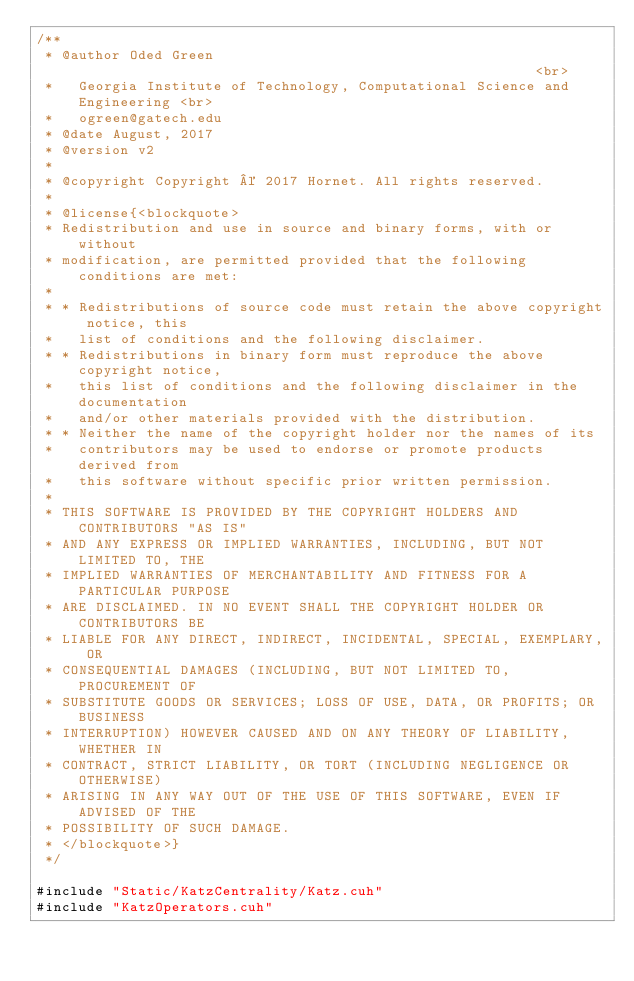<code> <loc_0><loc_0><loc_500><loc_500><_Cuda_>/**
 * @author Oded Green                                                       <br>
 *   Georgia Institute of Technology, Computational Science and Engineering <br>
 *   ogreen@gatech.edu
 * @date August, 2017
 * @version v2
 *
 * @copyright Copyright © 2017 Hornet. All rights reserved.
 *
 * @license{<blockquote>
 * Redistribution and use in source and binary forms, with or without
 * modification, are permitted provided that the following conditions are met:
 *
 * * Redistributions of source code must retain the above copyright notice, this
 *   list of conditions and the following disclaimer.
 * * Redistributions in binary form must reproduce the above copyright notice,
 *   this list of conditions and the following disclaimer in the documentation
 *   and/or other materials provided with the distribution.
 * * Neither the name of the copyright holder nor the names of its
 *   contributors may be used to endorse or promote products derived from
 *   this software without specific prior written permission.
 *
 * THIS SOFTWARE IS PROVIDED BY THE COPYRIGHT HOLDERS AND CONTRIBUTORS "AS IS"
 * AND ANY EXPRESS OR IMPLIED WARRANTIES, INCLUDING, BUT NOT LIMITED TO, THE
 * IMPLIED WARRANTIES OF MERCHANTABILITY AND FITNESS FOR A PARTICULAR PURPOSE
 * ARE DISCLAIMED. IN NO EVENT SHALL THE COPYRIGHT HOLDER OR CONTRIBUTORS BE
 * LIABLE FOR ANY DIRECT, INDIRECT, INCIDENTAL, SPECIAL, EXEMPLARY, OR
 * CONSEQUENTIAL DAMAGES (INCLUDING, BUT NOT LIMITED TO, PROCUREMENT OF
 * SUBSTITUTE GOODS OR SERVICES; LOSS OF USE, DATA, OR PROFITS; OR BUSINESS
 * INTERRUPTION) HOWEVER CAUSED AND ON ANY THEORY OF LIABILITY, WHETHER IN
 * CONTRACT, STRICT LIABILITY, OR TORT (INCLUDING NEGLIGENCE OR OTHERWISE)
 * ARISING IN ANY WAY OUT OF THE USE OF THIS SOFTWARE, EVEN IF ADVISED OF THE
 * POSSIBILITY OF SUCH DAMAGE.
 * </blockquote>}
 */

#include "Static/KatzCentrality/Katz.cuh"
#include "KatzOperators.cuh"
</code> 